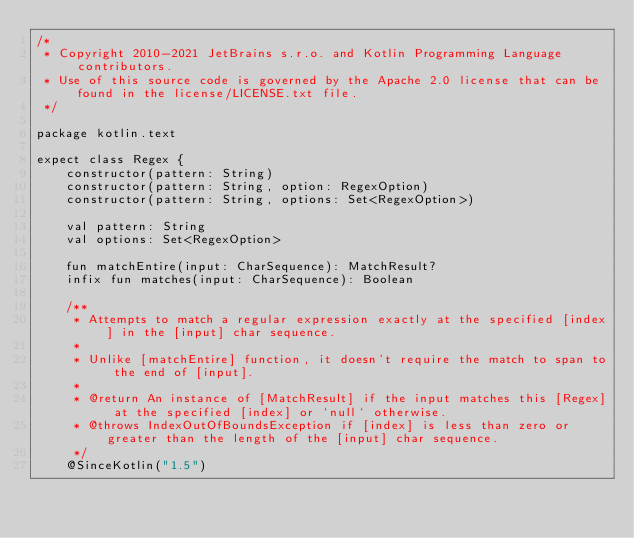Convert code to text. <code><loc_0><loc_0><loc_500><loc_500><_Kotlin_>/*
 * Copyright 2010-2021 JetBrains s.r.o. and Kotlin Programming Language contributors.
 * Use of this source code is governed by the Apache 2.0 license that can be found in the license/LICENSE.txt file.
 */

package kotlin.text

expect class Regex {
    constructor(pattern: String)
    constructor(pattern: String, option: RegexOption)
    constructor(pattern: String, options: Set<RegexOption>)

    val pattern: String
    val options: Set<RegexOption>

    fun matchEntire(input: CharSequence): MatchResult?
    infix fun matches(input: CharSequence): Boolean

    /**
     * Attempts to match a regular expression exactly at the specified [index] in the [input] char sequence.
     *
     * Unlike [matchEntire] function, it doesn't require the match to span to the end of [input].
     *
     * @return An instance of [MatchResult] if the input matches this [Regex] at the specified [index] or `null` otherwise.
     * @throws IndexOutOfBoundsException if [index] is less than zero or greater than the length of the [input] char sequence.
     */
    @SinceKotlin("1.5")</code> 